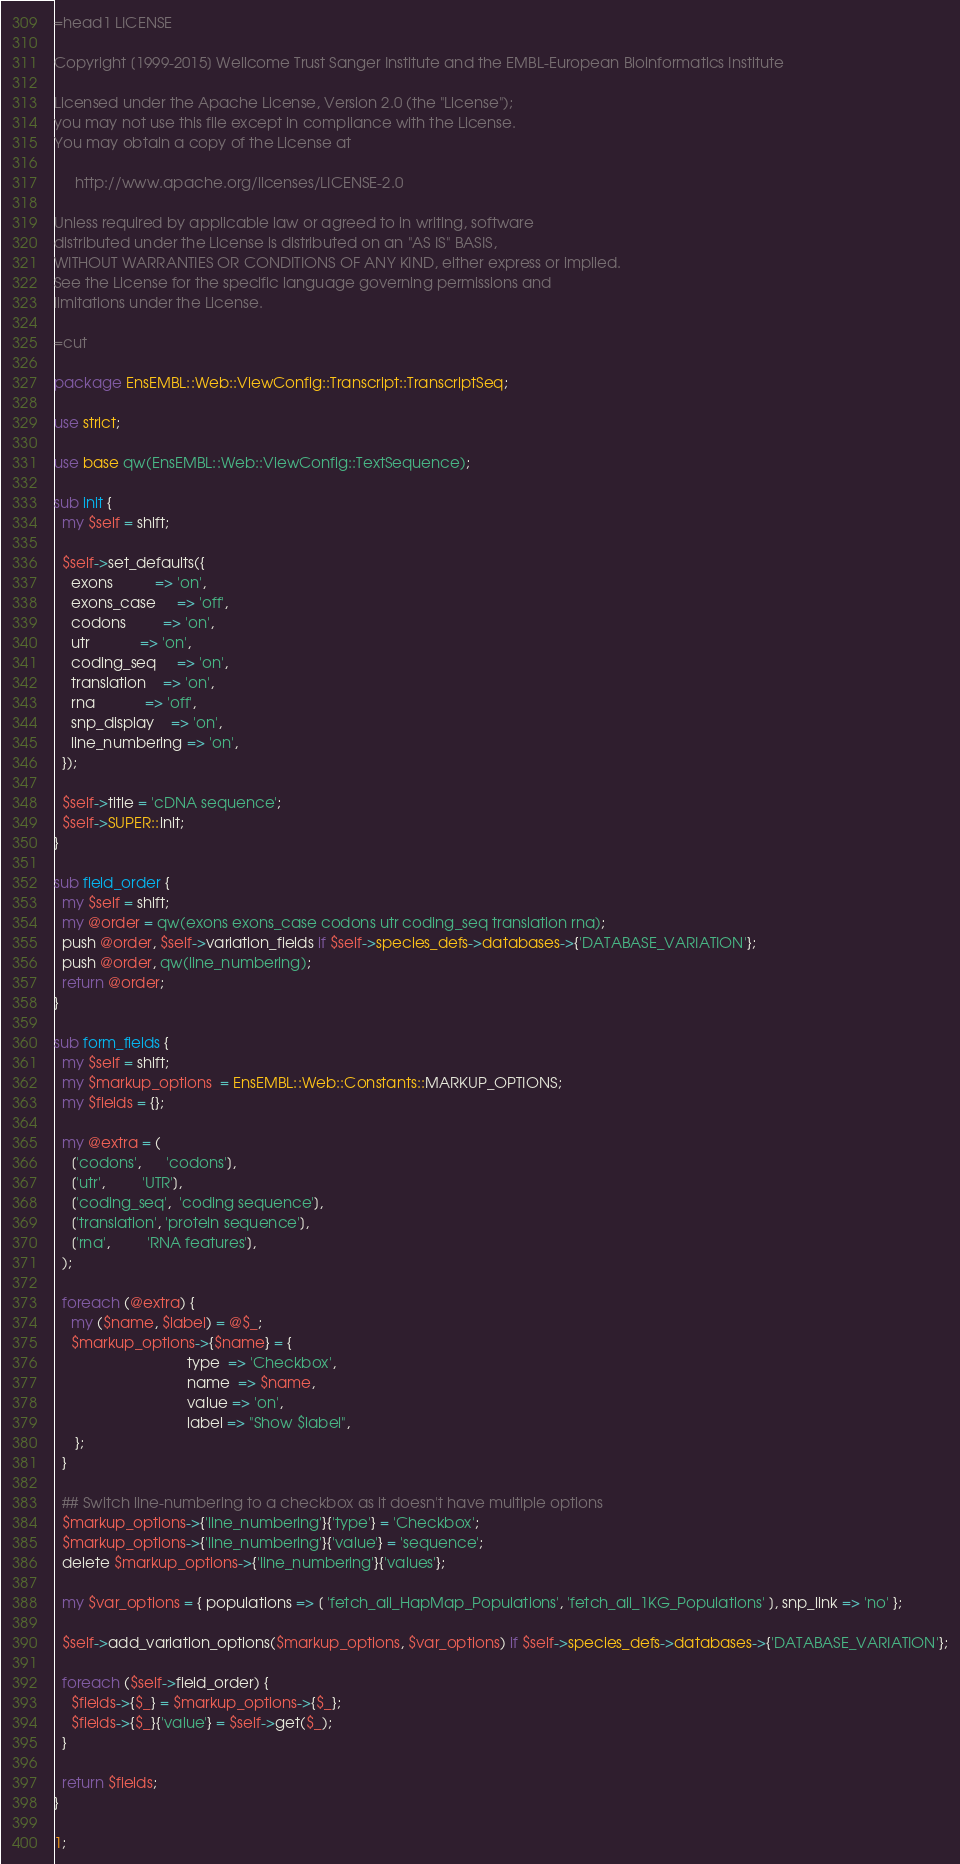Convert code to text. <code><loc_0><loc_0><loc_500><loc_500><_Perl_>=head1 LICENSE

Copyright [1999-2015] Wellcome Trust Sanger Institute and the EMBL-European Bioinformatics Institute

Licensed under the Apache License, Version 2.0 (the "License");
you may not use this file except in compliance with the License.
You may obtain a copy of the License at

     http://www.apache.org/licenses/LICENSE-2.0

Unless required by applicable law or agreed to in writing, software
distributed under the License is distributed on an "AS IS" BASIS,
WITHOUT WARRANTIES OR CONDITIONS OF ANY KIND, either express or implied.
See the License for the specific language governing permissions and
limitations under the License.

=cut

package EnsEMBL::Web::ViewConfig::Transcript::TranscriptSeq;

use strict;

use base qw(EnsEMBL::Web::ViewConfig::TextSequence);

sub init {
  my $self = shift;
  
  $self->set_defaults({
    exons          => 'on',
    exons_case     => 'off',
    codons         => 'on',
    utr            => 'on',
    coding_seq     => 'on',
    translation    => 'on',
    rna            => 'off',
    snp_display    => 'on',
    line_numbering => 'on',
  });
  
  $self->title = 'cDNA sequence';
  $self->SUPER::init;
}

sub field_order {
  my $self = shift;
  my @order = qw(exons exons_case codons utr coding_seq translation rna);
  push @order, $self->variation_fields if $self->species_defs->databases->{'DATABASE_VARIATION'};
  push @order, qw(line_numbering);
  return @order;
}

sub form_fields {
  my $self = shift;
  my $markup_options  = EnsEMBL::Web::Constants::MARKUP_OPTIONS;
  my $fields = {};

  my @extra = (
    ['codons',      'codons'],
    ['utr',         'UTR'],
    ['coding_seq',  'coding sequence'],
    ['translation', 'protein sequence'],
    ['rna',         'RNA features'],
  );

  foreach (@extra) {
    my ($name, $label) = @$_;
    $markup_options->{$name} = {
                                type  => 'Checkbox', 
                                name  => $name,
                                value => 'on',       
                                label => "Show $label",         
     };
  }

  ## Switch line-numbering to a checkbox as it doesn't have multiple options
  $markup_options->{'line_numbering'}{'type'} = 'Checkbox';
  $markup_options->{'line_numbering'}{'value'} = 'sequence';
  delete $markup_options->{'line_numbering'}{'values'};

  my $var_options = { populations => [ 'fetch_all_HapMap_Populations', 'fetch_all_1KG_Populations' ], snp_link => 'no' };

  $self->add_variation_options($markup_options, $var_options) if $self->species_defs->databases->{'DATABASE_VARIATION'};

  foreach ($self->field_order) {
    $fields->{$_} = $markup_options->{$_};
    $fields->{$_}{'value'} = $self->get($_);
  }

  return $fields;
}

1;
</code> 